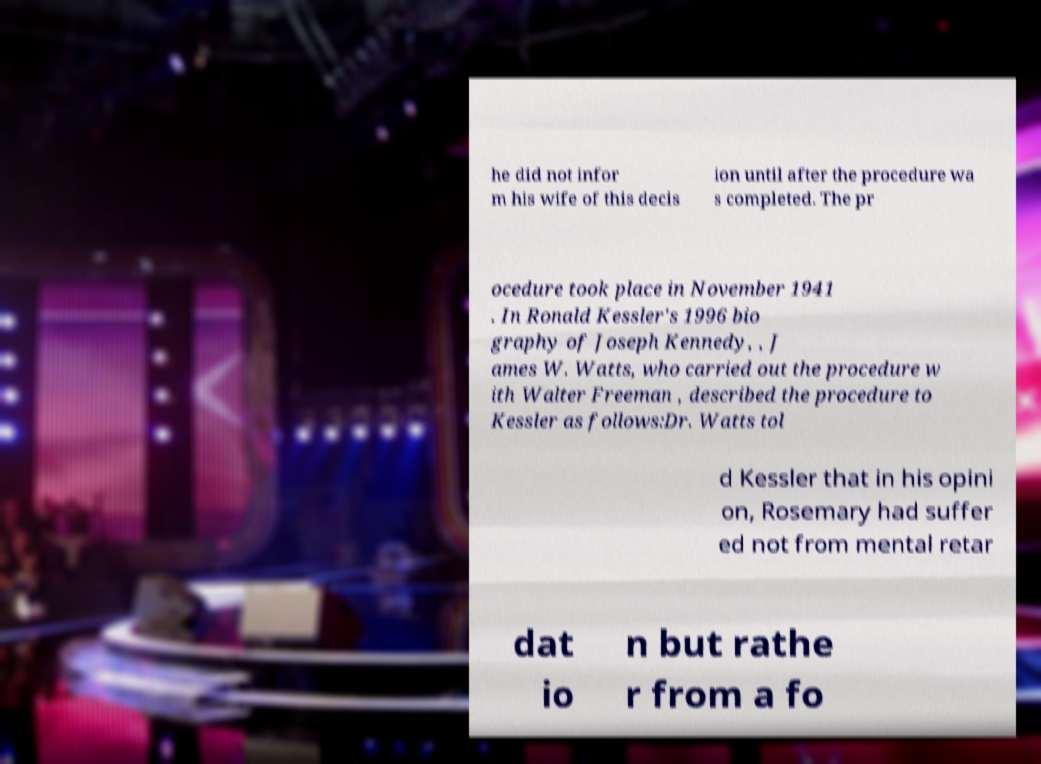Please identify and transcribe the text found in this image. he did not infor m his wife of this decis ion until after the procedure wa s completed. The pr ocedure took place in November 1941 . In Ronald Kessler's 1996 bio graphy of Joseph Kennedy, , J ames W. Watts, who carried out the procedure w ith Walter Freeman , described the procedure to Kessler as follows:Dr. Watts tol d Kessler that in his opini on, Rosemary had suffer ed not from mental retar dat io n but rathe r from a fo 